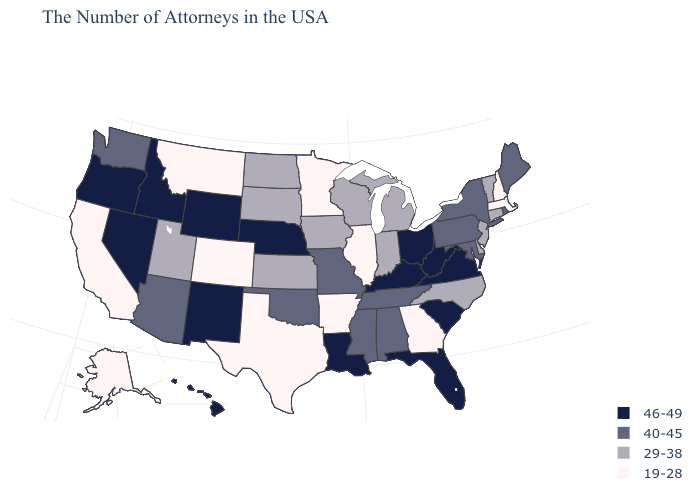Among the states that border North Dakota , does South Dakota have the lowest value?
Concise answer only. No. Name the states that have a value in the range 46-49?
Give a very brief answer. Virginia, South Carolina, West Virginia, Ohio, Florida, Kentucky, Louisiana, Nebraska, Wyoming, New Mexico, Idaho, Nevada, Oregon, Hawaii. Which states have the lowest value in the Northeast?
Concise answer only. Massachusetts, New Hampshire. Among the states that border Virginia , does North Carolina have the highest value?
Write a very short answer. No. Name the states that have a value in the range 19-28?
Be succinct. Massachusetts, New Hampshire, Georgia, Illinois, Arkansas, Minnesota, Texas, Colorado, Montana, California, Alaska. What is the highest value in the MidWest ?
Write a very short answer. 46-49. What is the lowest value in the South?
Quick response, please. 19-28. How many symbols are there in the legend?
Write a very short answer. 4. What is the lowest value in the South?
Give a very brief answer. 19-28. What is the value of Alaska?
Concise answer only. 19-28. Name the states that have a value in the range 46-49?
Keep it brief. Virginia, South Carolina, West Virginia, Ohio, Florida, Kentucky, Louisiana, Nebraska, Wyoming, New Mexico, Idaho, Nevada, Oregon, Hawaii. Name the states that have a value in the range 29-38?
Short answer required. Vermont, Connecticut, New Jersey, Delaware, North Carolina, Michigan, Indiana, Wisconsin, Iowa, Kansas, South Dakota, North Dakota, Utah. Is the legend a continuous bar?
Give a very brief answer. No. What is the highest value in the USA?
Short answer required. 46-49. 